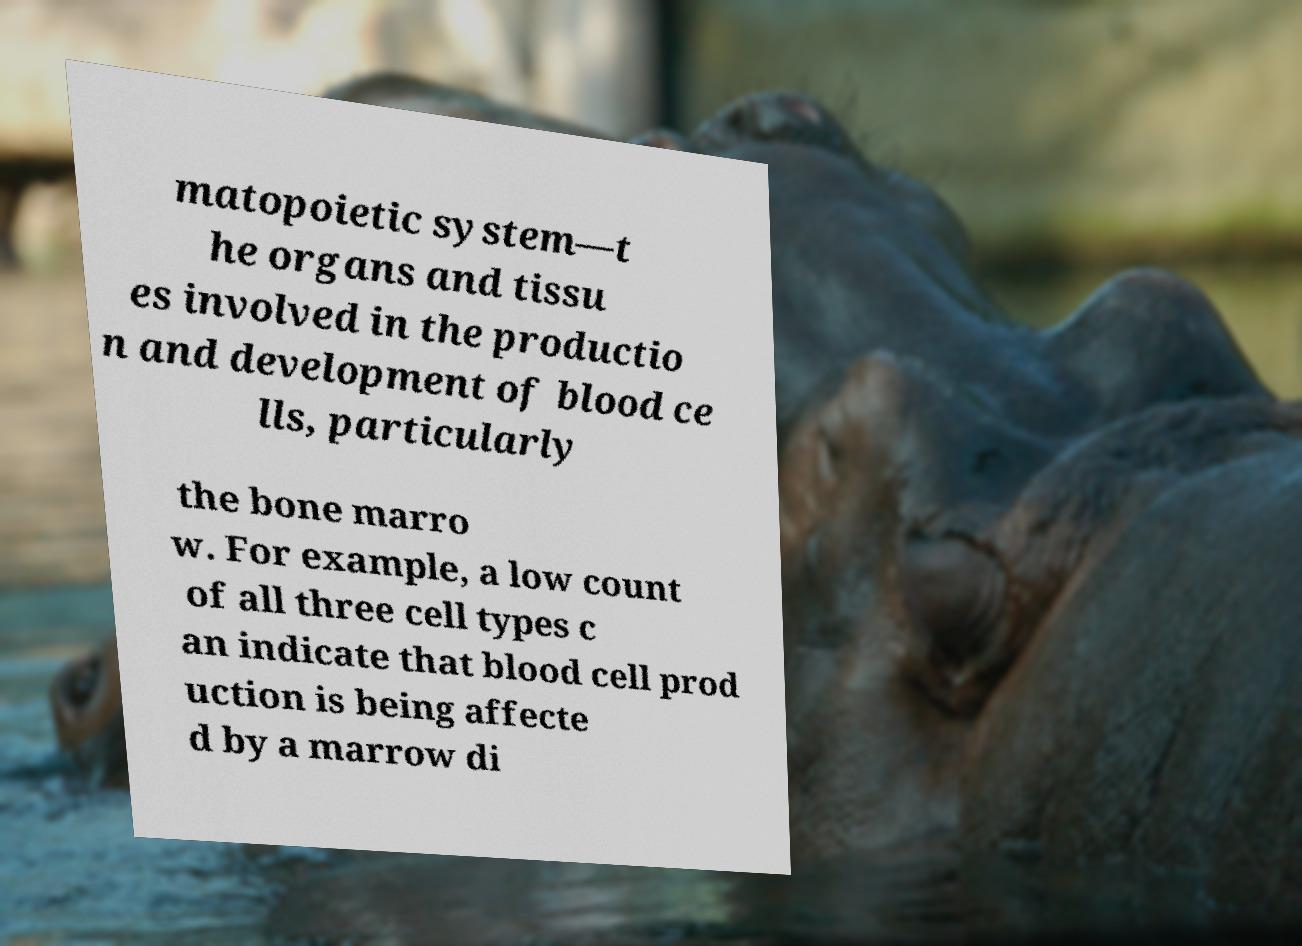Could you extract and type out the text from this image? matopoietic system—t he organs and tissu es involved in the productio n and development of blood ce lls, particularly the bone marro w. For example, a low count of all three cell types c an indicate that blood cell prod uction is being affecte d by a marrow di 